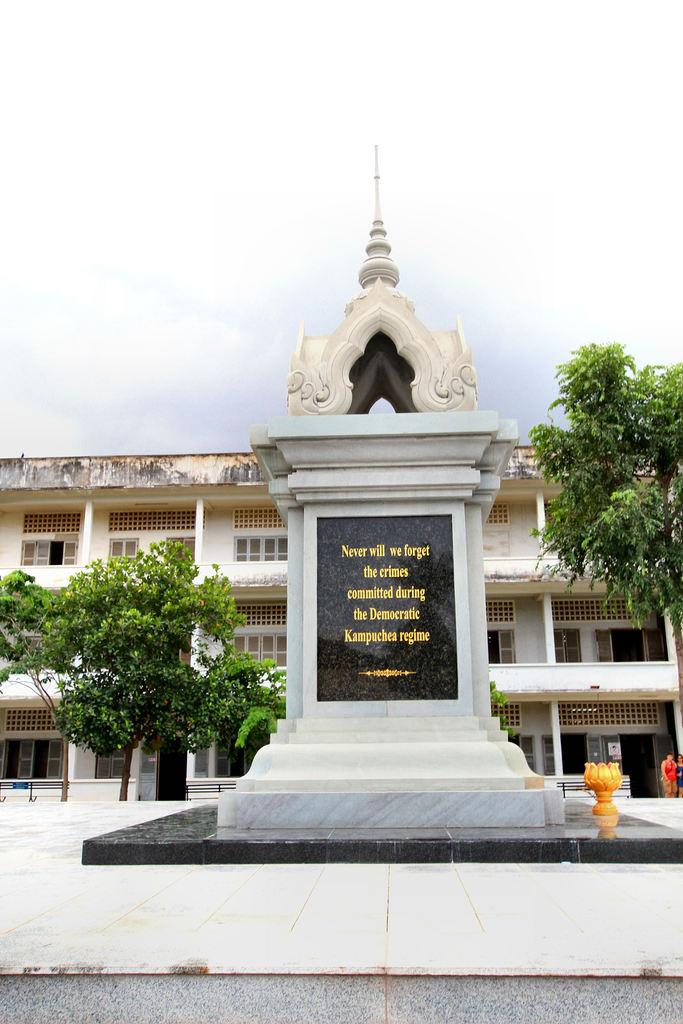<image>
Write a terse but informative summary of the picture. A memorial for the crimes committed during the Democratic Kampuchea regime 